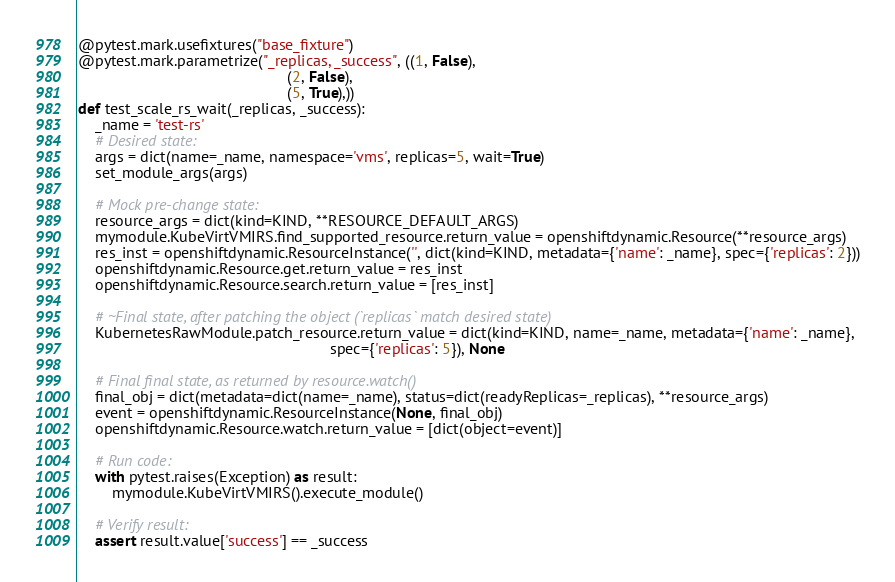Convert code to text. <code><loc_0><loc_0><loc_500><loc_500><_Python_>@pytest.mark.usefixtures("base_fixture")
@pytest.mark.parametrize("_replicas, _success", ((1, False),
                                                 (2, False),
                                                 (5, True),))
def test_scale_rs_wait(_replicas, _success):
    _name = 'test-rs'
    # Desired state:
    args = dict(name=_name, namespace='vms', replicas=5, wait=True)
    set_module_args(args)

    # Mock pre-change state:
    resource_args = dict(kind=KIND, **RESOURCE_DEFAULT_ARGS)
    mymodule.KubeVirtVMIRS.find_supported_resource.return_value = openshiftdynamic.Resource(**resource_args)
    res_inst = openshiftdynamic.ResourceInstance('', dict(kind=KIND, metadata={'name': _name}, spec={'replicas': 2}))
    openshiftdynamic.Resource.get.return_value = res_inst
    openshiftdynamic.Resource.search.return_value = [res_inst]

    # ~Final state, after patching the object (`replicas` match desired state)
    KubernetesRawModule.patch_resource.return_value = dict(kind=KIND, name=_name, metadata={'name': _name},
                                                           spec={'replicas': 5}), None

    # Final final state, as returned by resource.watch()
    final_obj = dict(metadata=dict(name=_name), status=dict(readyReplicas=_replicas), **resource_args)
    event = openshiftdynamic.ResourceInstance(None, final_obj)
    openshiftdynamic.Resource.watch.return_value = [dict(object=event)]

    # Run code:
    with pytest.raises(Exception) as result:
        mymodule.KubeVirtVMIRS().execute_module()

    # Verify result:
    assert result.value['success'] == _success
</code> 